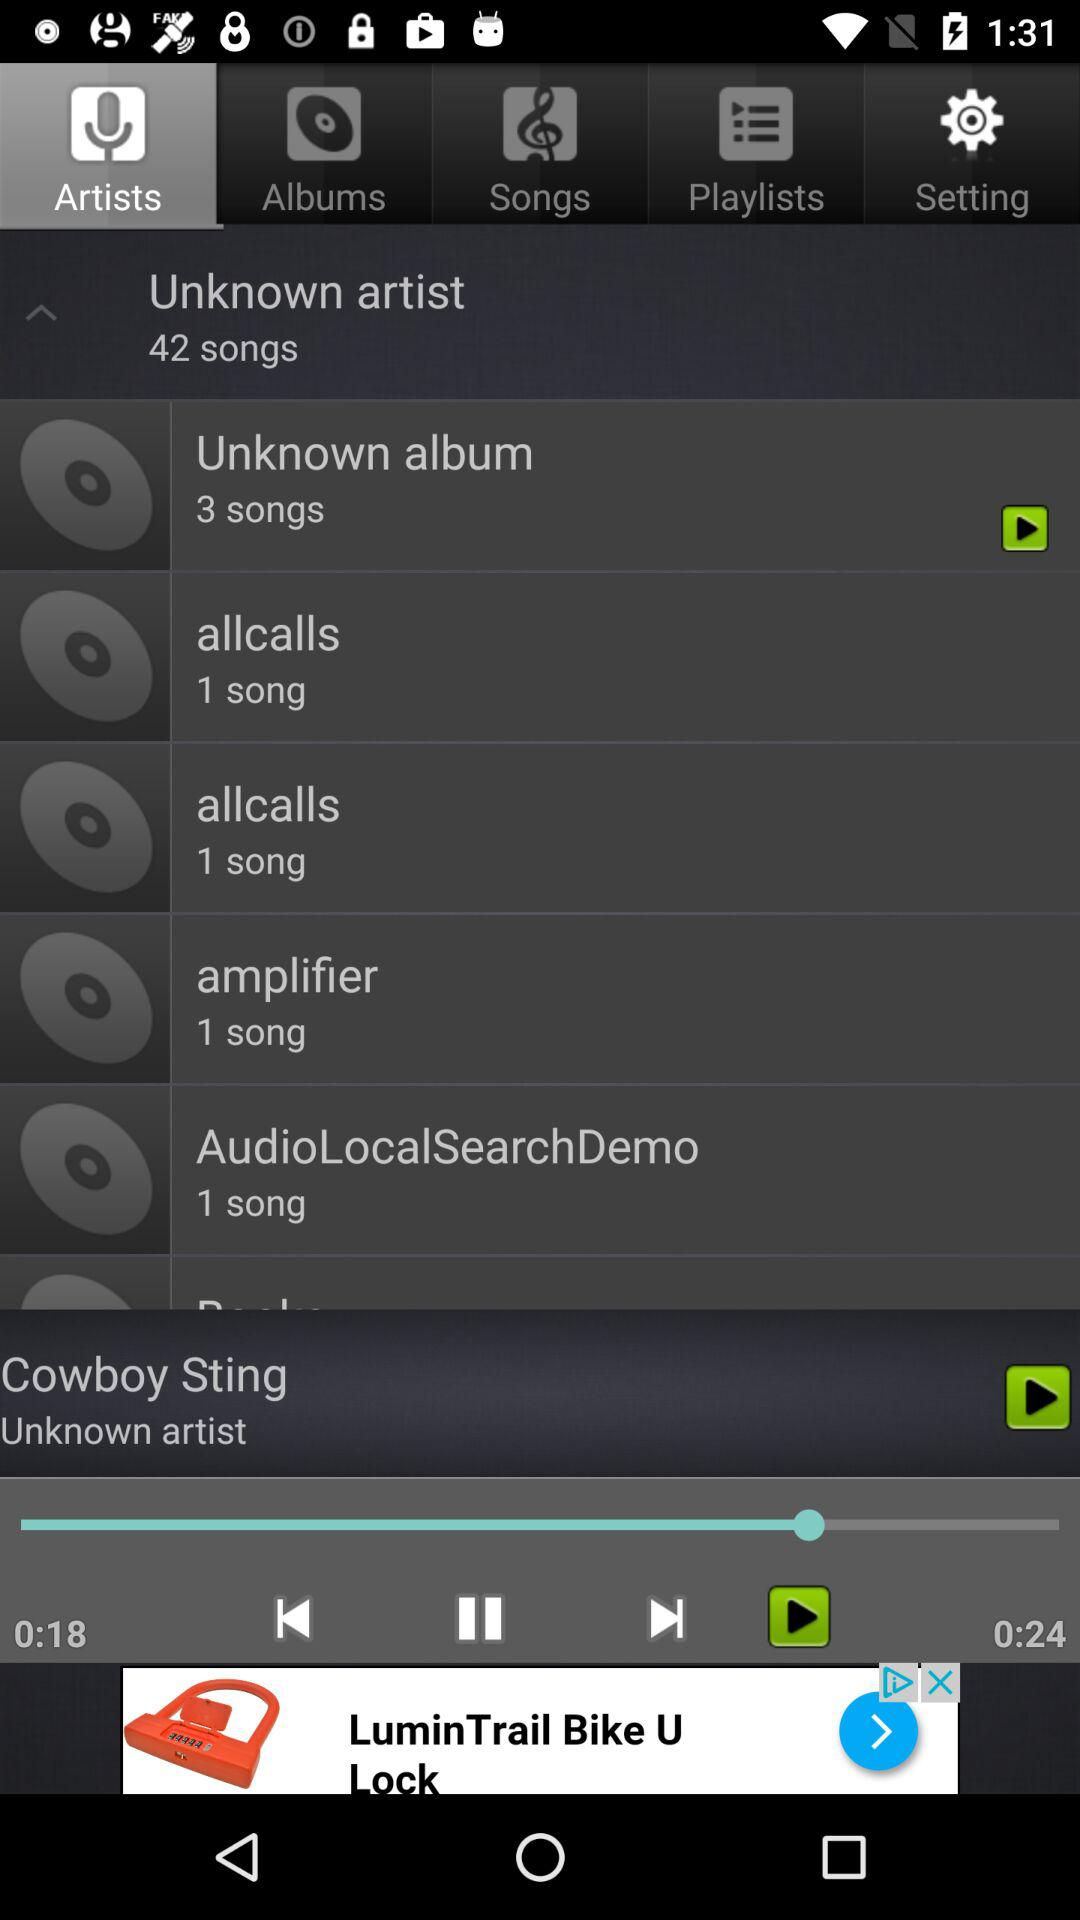How many songs are there in the Unknown album? There are 3 songs in the Unknown album. 